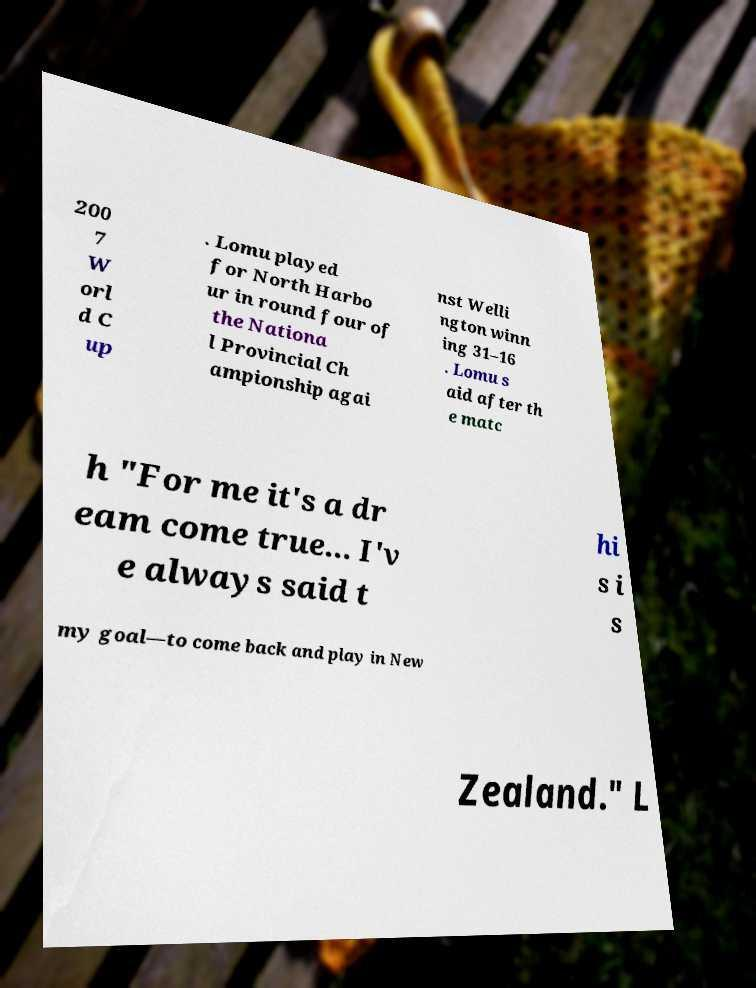Can you accurately transcribe the text from the provided image for me? 200 7 W orl d C up . Lomu played for North Harbo ur in round four of the Nationa l Provincial Ch ampionship agai nst Welli ngton winn ing 31–16 . Lomu s aid after th e matc h "For me it's a dr eam come true... I'v e always said t hi s i s my goal—to come back and play in New Zealand." L 